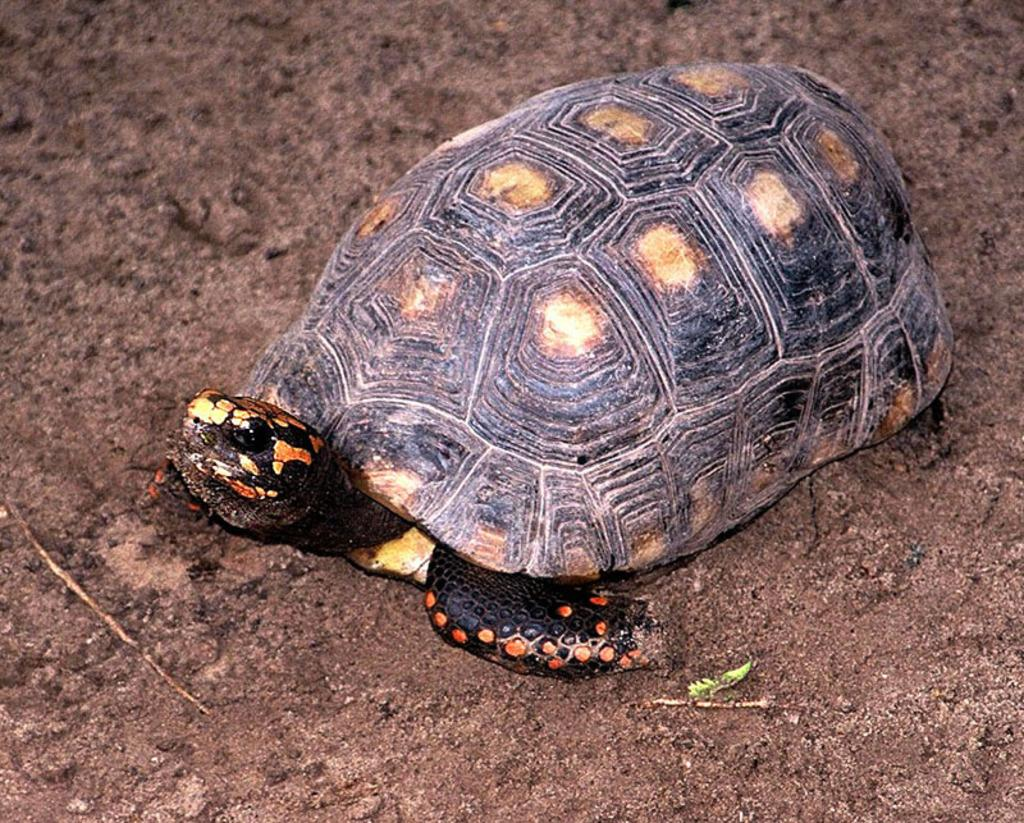What animal can be seen in the image? There is a turtle in the image. Where is the turtle located? The turtle is on the ground. Does the turtle have any visible features? Yes, the turtle has an eye. What type of terrain is present in the image? There is mud in the image. What type of drink is being served in the image? There is no drink present in the image; it features a turtle on the ground with mud. How does the grain affect the growth of the turtle in the image? There is no grain present in the image, and the turtle's growth is not mentioned or depicted. 